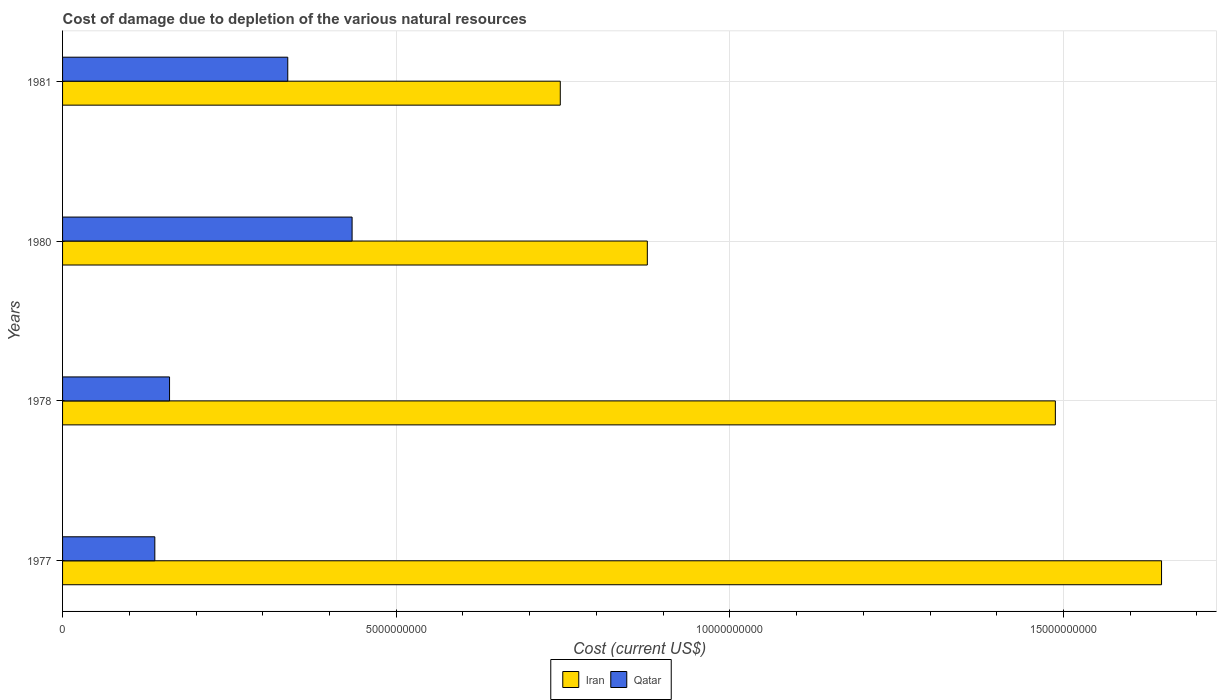How many different coloured bars are there?
Offer a very short reply. 2. Are the number of bars per tick equal to the number of legend labels?
Provide a short and direct response. Yes. What is the label of the 3rd group of bars from the top?
Provide a short and direct response. 1978. What is the cost of damage caused due to the depletion of various natural resources in Qatar in 1981?
Ensure brevity in your answer.  3.38e+09. Across all years, what is the maximum cost of damage caused due to the depletion of various natural resources in Qatar?
Your answer should be very brief. 4.34e+09. Across all years, what is the minimum cost of damage caused due to the depletion of various natural resources in Qatar?
Ensure brevity in your answer.  1.38e+09. In which year was the cost of damage caused due to the depletion of various natural resources in Iran minimum?
Make the answer very short. 1981. What is the total cost of damage caused due to the depletion of various natural resources in Iran in the graph?
Provide a succinct answer. 4.76e+1. What is the difference between the cost of damage caused due to the depletion of various natural resources in Qatar in 1980 and that in 1981?
Make the answer very short. 9.64e+08. What is the difference between the cost of damage caused due to the depletion of various natural resources in Qatar in 1981 and the cost of damage caused due to the depletion of various natural resources in Iran in 1980?
Make the answer very short. -5.39e+09. What is the average cost of damage caused due to the depletion of various natural resources in Iran per year?
Offer a very short reply. 1.19e+1. In the year 1977, what is the difference between the cost of damage caused due to the depletion of various natural resources in Qatar and cost of damage caused due to the depletion of various natural resources in Iran?
Keep it short and to the point. -1.51e+1. In how many years, is the cost of damage caused due to the depletion of various natural resources in Qatar greater than 1000000000 US$?
Your response must be concise. 4. What is the ratio of the cost of damage caused due to the depletion of various natural resources in Qatar in 1977 to that in 1978?
Keep it short and to the point. 0.86. Is the cost of damage caused due to the depletion of various natural resources in Iran in 1978 less than that in 1981?
Provide a short and direct response. No. Is the difference between the cost of damage caused due to the depletion of various natural resources in Qatar in 1977 and 1981 greater than the difference between the cost of damage caused due to the depletion of various natural resources in Iran in 1977 and 1981?
Your answer should be very brief. No. What is the difference between the highest and the second highest cost of damage caused due to the depletion of various natural resources in Iran?
Make the answer very short. 1.59e+09. What is the difference between the highest and the lowest cost of damage caused due to the depletion of various natural resources in Iran?
Provide a succinct answer. 9.01e+09. In how many years, is the cost of damage caused due to the depletion of various natural resources in Iran greater than the average cost of damage caused due to the depletion of various natural resources in Iran taken over all years?
Give a very brief answer. 2. What does the 2nd bar from the top in 1978 represents?
Ensure brevity in your answer.  Iran. What does the 1st bar from the bottom in 1977 represents?
Provide a short and direct response. Iran. Are all the bars in the graph horizontal?
Your response must be concise. Yes. Does the graph contain any zero values?
Your answer should be compact. No. Where does the legend appear in the graph?
Make the answer very short. Bottom center. How are the legend labels stacked?
Give a very brief answer. Horizontal. What is the title of the graph?
Your answer should be very brief. Cost of damage due to depletion of the various natural resources. Does "Middle income" appear as one of the legend labels in the graph?
Your answer should be compact. No. What is the label or title of the X-axis?
Provide a short and direct response. Cost (current US$). What is the label or title of the Y-axis?
Provide a succinct answer. Years. What is the Cost (current US$) of Iran in 1977?
Provide a succinct answer. 1.65e+1. What is the Cost (current US$) of Qatar in 1977?
Keep it short and to the point. 1.38e+09. What is the Cost (current US$) of Iran in 1978?
Your response must be concise. 1.49e+1. What is the Cost (current US$) of Qatar in 1978?
Your answer should be compact. 1.60e+09. What is the Cost (current US$) of Iran in 1980?
Offer a terse response. 8.76e+09. What is the Cost (current US$) of Qatar in 1980?
Provide a succinct answer. 4.34e+09. What is the Cost (current US$) of Iran in 1981?
Make the answer very short. 7.46e+09. What is the Cost (current US$) in Qatar in 1981?
Your answer should be compact. 3.38e+09. Across all years, what is the maximum Cost (current US$) of Iran?
Keep it short and to the point. 1.65e+1. Across all years, what is the maximum Cost (current US$) of Qatar?
Ensure brevity in your answer.  4.34e+09. Across all years, what is the minimum Cost (current US$) in Iran?
Your response must be concise. 7.46e+09. Across all years, what is the minimum Cost (current US$) in Qatar?
Give a very brief answer. 1.38e+09. What is the total Cost (current US$) of Iran in the graph?
Provide a succinct answer. 4.76e+1. What is the total Cost (current US$) in Qatar in the graph?
Offer a terse response. 1.07e+1. What is the difference between the Cost (current US$) in Iran in 1977 and that in 1978?
Offer a very short reply. 1.59e+09. What is the difference between the Cost (current US$) in Qatar in 1977 and that in 1978?
Provide a short and direct response. -2.21e+08. What is the difference between the Cost (current US$) in Iran in 1977 and that in 1980?
Your response must be concise. 7.71e+09. What is the difference between the Cost (current US$) in Qatar in 1977 and that in 1980?
Offer a terse response. -2.96e+09. What is the difference between the Cost (current US$) of Iran in 1977 and that in 1981?
Provide a succinct answer. 9.01e+09. What is the difference between the Cost (current US$) in Qatar in 1977 and that in 1981?
Make the answer very short. -1.99e+09. What is the difference between the Cost (current US$) in Iran in 1978 and that in 1980?
Ensure brevity in your answer.  6.12e+09. What is the difference between the Cost (current US$) in Qatar in 1978 and that in 1980?
Your answer should be very brief. -2.74e+09. What is the difference between the Cost (current US$) of Iran in 1978 and that in 1981?
Ensure brevity in your answer.  7.42e+09. What is the difference between the Cost (current US$) of Qatar in 1978 and that in 1981?
Provide a short and direct response. -1.77e+09. What is the difference between the Cost (current US$) in Iran in 1980 and that in 1981?
Keep it short and to the point. 1.30e+09. What is the difference between the Cost (current US$) in Qatar in 1980 and that in 1981?
Your response must be concise. 9.64e+08. What is the difference between the Cost (current US$) in Iran in 1977 and the Cost (current US$) in Qatar in 1978?
Offer a very short reply. 1.49e+1. What is the difference between the Cost (current US$) in Iran in 1977 and the Cost (current US$) in Qatar in 1980?
Offer a terse response. 1.21e+1. What is the difference between the Cost (current US$) in Iran in 1977 and the Cost (current US$) in Qatar in 1981?
Keep it short and to the point. 1.31e+1. What is the difference between the Cost (current US$) in Iran in 1978 and the Cost (current US$) in Qatar in 1980?
Your response must be concise. 1.05e+1. What is the difference between the Cost (current US$) in Iran in 1978 and the Cost (current US$) in Qatar in 1981?
Your answer should be very brief. 1.15e+1. What is the difference between the Cost (current US$) of Iran in 1980 and the Cost (current US$) of Qatar in 1981?
Your answer should be compact. 5.39e+09. What is the average Cost (current US$) in Iran per year?
Your response must be concise. 1.19e+1. What is the average Cost (current US$) of Qatar per year?
Make the answer very short. 2.68e+09. In the year 1977, what is the difference between the Cost (current US$) in Iran and Cost (current US$) in Qatar?
Ensure brevity in your answer.  1.51e+1. In the year 1978, what is the difference between the Cost (current US$) of Iran and Cost (current US$) of Qatar?
Give a very brief answer. 1.33e+1. In the year 1980, what is the difference between the Cost (current US$) in Iran and Cost (current US$) in Qatar?
Your answer should be compact. 4.42e+09. In the year 1981, what is the difference between the Cost (current US$) in Iran and Cost (current US$) in Qatar?
Your answer should be compact. 4.08e+09. What is the ratio of the Cost (current US$) in Iran in 1977 to that in 1978?
Ensure brevity in your answer.  1.11. What is the ratio of the Cost (current US$) in Qatar in 1977 to that in 1978?
Give a very brief answer. 0.86. What is the ratio of the Cost (current US$) in Iran in 1977 to that in 1980?
Your response must be concise. 1.88. What is the ratio of the Cost (current US$) in Qatar in 1977 to that in 1980?
Offer a very short reply. 0.32. What is the ratio of the Cost (current US$) of Iran in 1977 to that in 1981?
Your answer should be very brief. 2.21. What is the ratio of the Cost (current US$) of Qatar in 1977 to that in 1981?
Give a very brief answer. 0.41. What is the ratio of the Cost (current US$) of Iran in 1978 to that in 1980?
Provide a succinct answer. 1.7. What is the ratio of the Cost (current US$) in Qatar in 1978 to that in 1980?
Offer a terse response. 0.37. What is the ratio of the Cost (current US$) of Iran in 1978 to that in 1981?
Your response must be concise. 1.99. What is the ratio of the Cost (current US$) in Qatar in 1978 to that in 1981?
Keep it short and to the point. 0.47. What is the ratio of the Cost (current US$) of Iran in 1980 to that in 1981?
Your response must be concise. 1.17. What is the ratio of the Cost (current US$) of Qatar in 1980 to that in 1981?
Give a very brief answer. 1.29. What is the difference between the highest and the second highest Cost (current US$) in Iran?
Ensure brevity in your answer.  1.59e+09. What is the difference between the highest and the second highest Cost (current US$) of Qatar?
Provide a succinct answer. 9.64e+08. What is the difference between the highest and the lowest Cost (current US$) in Iran?
Your answer should be compact. 9.01e+09. What is the difference between the highest and the lowest Cost (current US$) of Qatar?
Your response must be concise. 2.96e+09. 